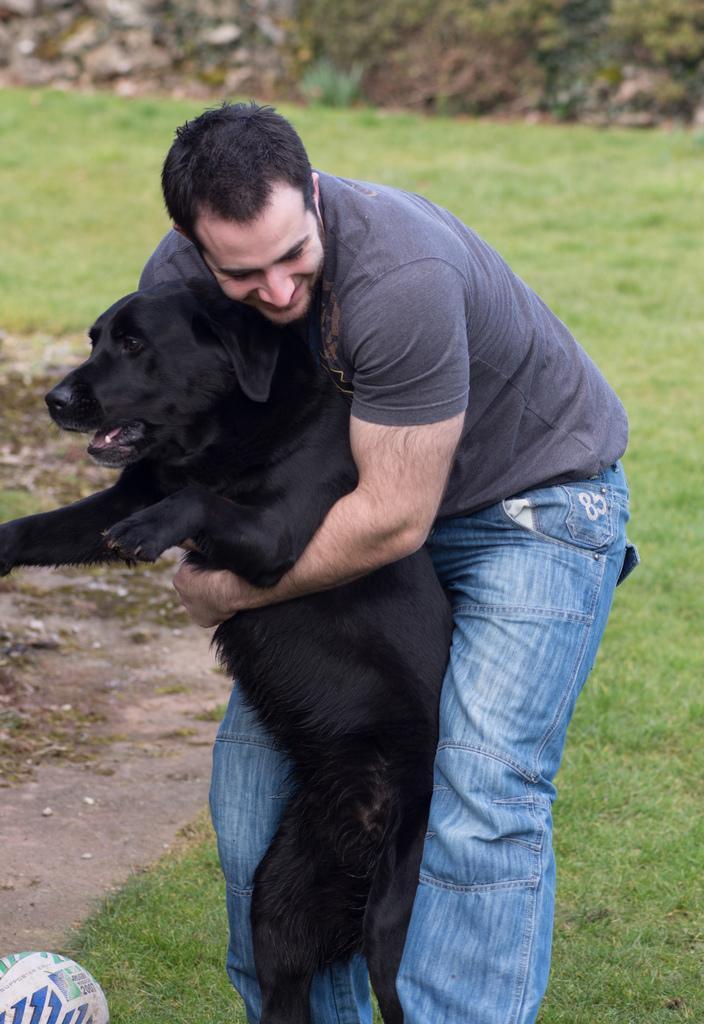How would you summarize this image in a sentence or two? In this image there is a man standing on the ground and holding the black dog. On the ground there is grass and mud. At the bottom there is a ball. 